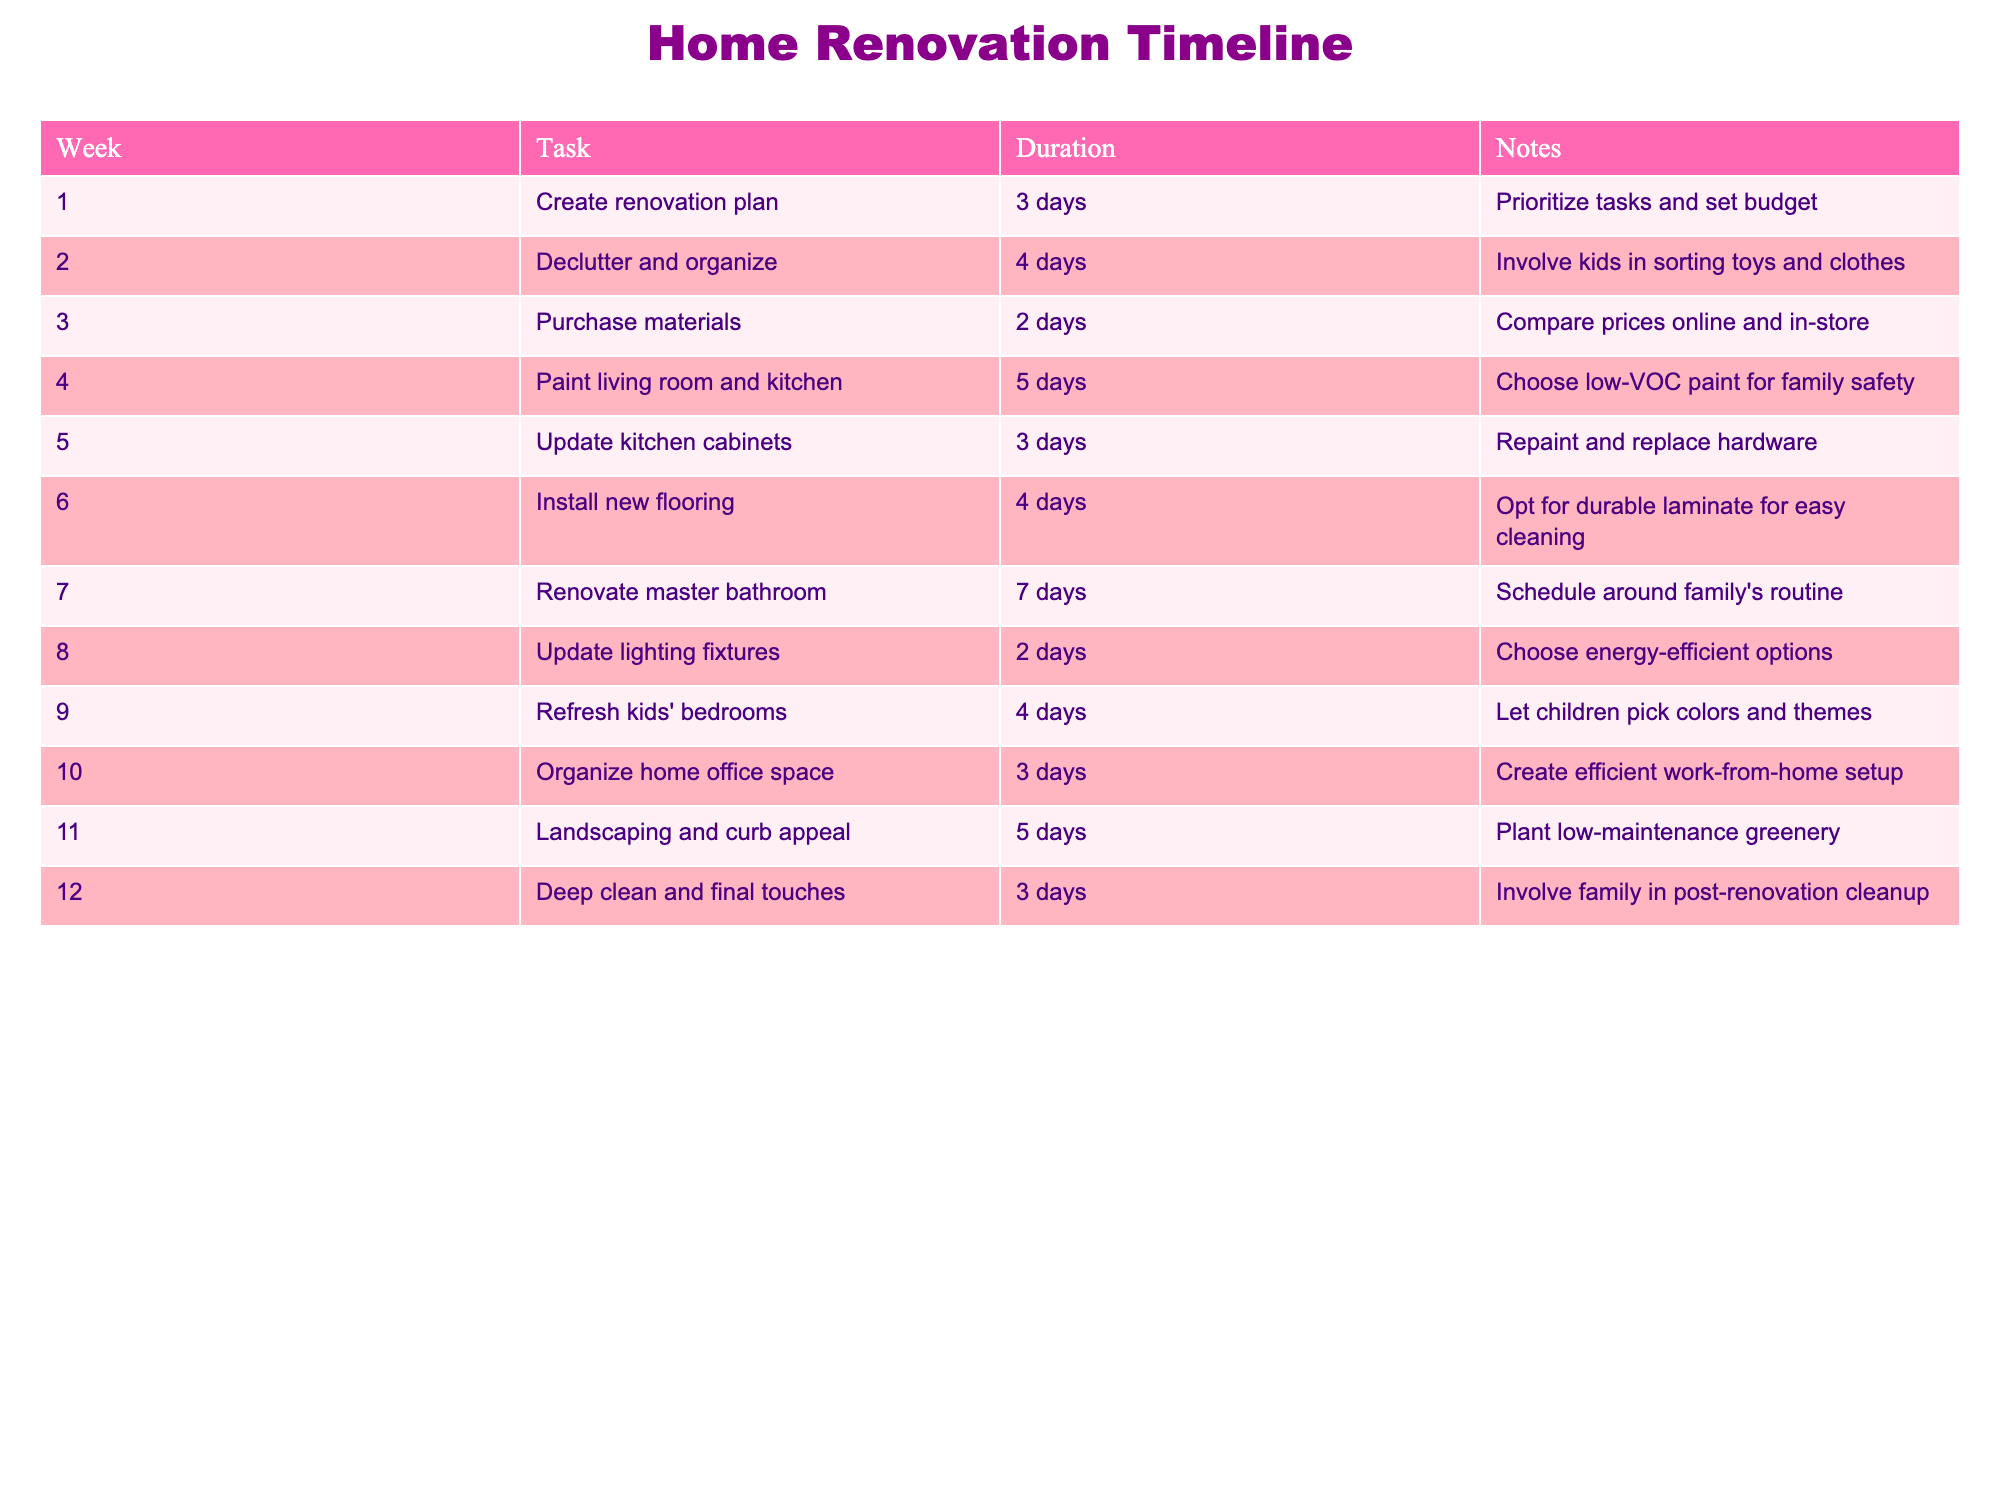What is the duration of the task to declutter and organize? The task "Declutter and organize" is listed in Week 2, and its duration is specified as 4 days in the table.
Answer: 4 days Which task has the longest duration? The task with the longest duration is "Renovate master bathroom," which takes 7 days as noted in Week 7 of the table.
Answer: 7 days How many days does it take to complete tasks related to painting and updating the kitchen? The task "Paint living room and kitchen" takes 5 days, while "Update kitchen cabinets" takes 3 days. Summing these gives 5 + 3 = 8 days for these specific tasks.
Answer: 8 days Is it true that landscaping has a duration longer than purchasing materials? "Landscaping and curb appeal" has a duration of 5 days (Week 11), while "Purchase materials" takes 2 days (Week 3). Therefore, landscaping does have a longer duration than purchasing materials.
Answer: Yes What is the total duration of tasks from Week 1 to Week 6? The tasks from Week 1 to Week 6 are as follows: 3 days (Create renovation plan) + 4 days (Declutter and organize) + 2 days (Purchase materials) + 5 days (Paint living room and kitchen) + 3 days (Update kitchen cabinets) + 4 days (Install new flooring). Adding these gives a total of 3 + 4 + 2 + 5 + 3 + 4 = 21 days.
Answer: 21 days How many tasks are related to kids' spaces in the timeline? There are two tasks related to kids' spaces: "Refresh kids' bedrooms," which takes 4 days in Week 9, and "Declutter and organize," where kids are involved. Therefore, there are 2 tasks regarding kids' spaces.
Answer: 2 tasks What is the average duration of all tasks listed in the timeline? The total duration of all tasks is 3 + 4 + 2 + 5 + 3 + 4 + 7 + 2 + 4 + 3 + 5 + 3 = 45 days. There are 12 tasks, so we calculate the average as 45 days / 12 tasks = 3.75 days.
Answer: 3.75 days Which task is focused on creating a work-from-home setup? The task "Organize home office space," listed in Week 10, focuses on creating an efficient work-from-home setup.
Answer: Organize home office space What is the duration difference between updating lighting fixtures and landscaping? "Update lighting fixtures" takes 2 days (Week 8), while "Landscaping and curb appeal" takes 5 days (Week 11). The difference in duration is calculated as 5 - 2 = 3 days.
Answer: 3 days 